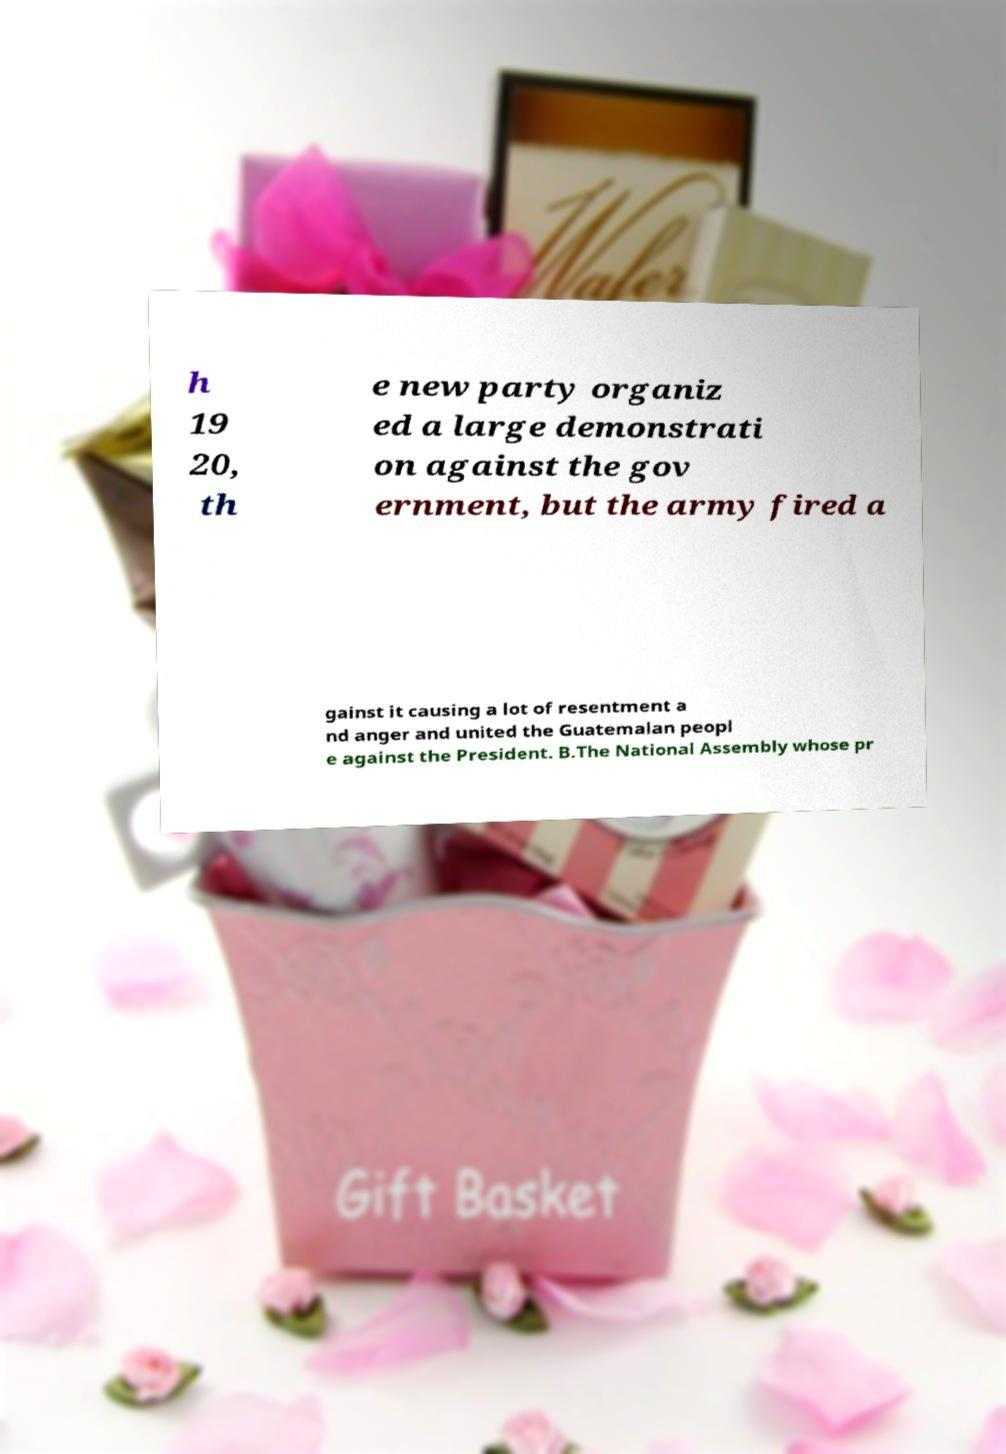For documentation purposes, I need the text within this image transcribed. Could you provide that? h 19 20, th e new party organiz ed a large demonstrati on against the gov ernment, but the army fired a gainst it causing a lot of resentment a nd anger and united the Guatemalan peopl e against the President. B.The National Assembly whose pr 